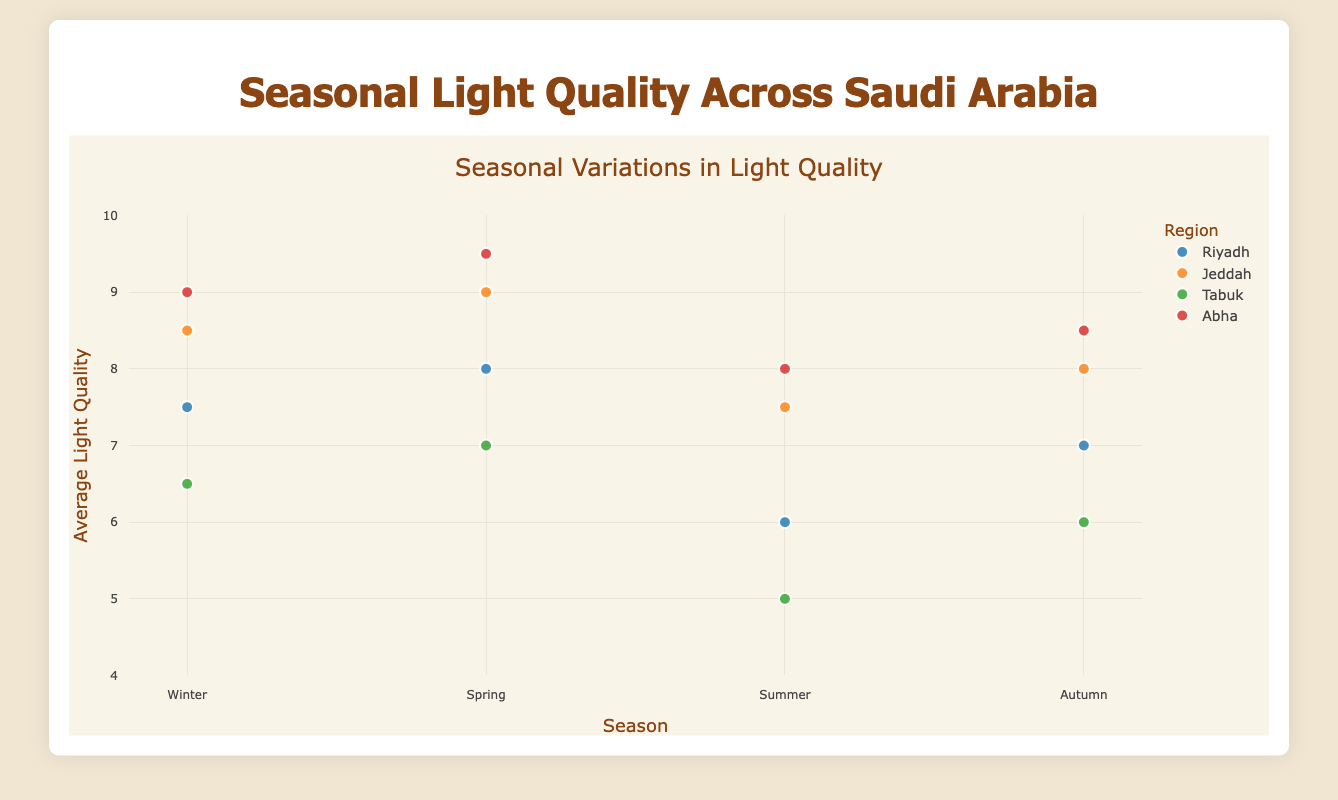What is the title of the figure? The title is located at the top of the figure and provides a brief summary of what the figure is about.
Answer: Seasonal Light Quality Across Saudi Arabia Which region has the highest average light quality in spring? To find this, locate the data points for each region in spring and identify the one with the highest y-value.
Answer: Abha How does the average light quality in Jeddah vary between winter and summer? Compare the y-values for Jeddah in winter and summer. Winter has a value of 8.5, and summer has a value of 7.5.
Answer: Winter has higher light quality than summer in Jeddah Which season generally has the lowest average light quality across all regions? Look for the season with consistently lower y-values across different regions and compare.
Answer: Summer What is the overall trend in seasonal light quality for Riyadh? Observe the data points for Riyadh across all seasons and note the changes in y-values.
Answer: The trend decreases from spring (8.0) to summer (6.0) and then increases in autumn (7.0) Which region shows the most consistent light quality across all seasons? Look for the region with the smallest range in y-values across different seasons. Abha varies between 8.0 and 9.5, which is a small range.
Answer: Abha What is the difference in average light quality between winter and autumn in Tabuk? Subtract the y-value for autumn from the y-value for winter in Tabuk. Winter is 6.5 and autumn is 6.0.
Answer: 0.5 Which region has the greatest fluctuation in light quality between seasons? Identify the region with the largest difference between its highest and lowest y-values. Tabuk ranges from 5.0 to 7.0, which is significant.
Answer: Tabuk Does any region have a higher average light quality in summer than in other seasons? Compare the summer y-values for each region with their respective y-values in other seasons to see if any summer value is the highest.
Answer: No What is the average light quality across all seasons for Jeddah? Add up Jeddah’s light quality values for all seasons (8.5 + 9.0 + 7.5 + 8.0) and divide by 4.
Answer: 8.25 